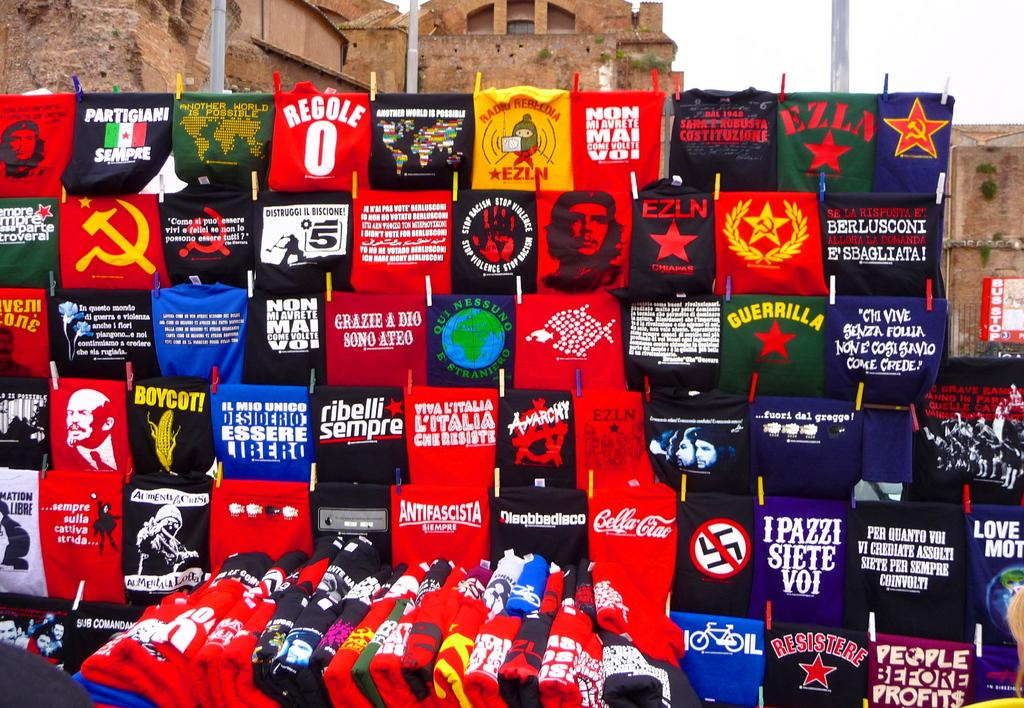What type of items can be seen in the image? There are clothes in the image. Can you describe the appearance of the clothes? The clothes have different colors, text, and pictures on them. What is visible in the background of the image? There is a building in the background of the image. How many muscles can be seen in the image? There are no muscles visible in the image; it features clothes with different colors, text, and pictures. What type of shoes are the clothes paired with in the image? There is no mention of shoes in the image; it only shows clothes with different colors, text, and pictures. 